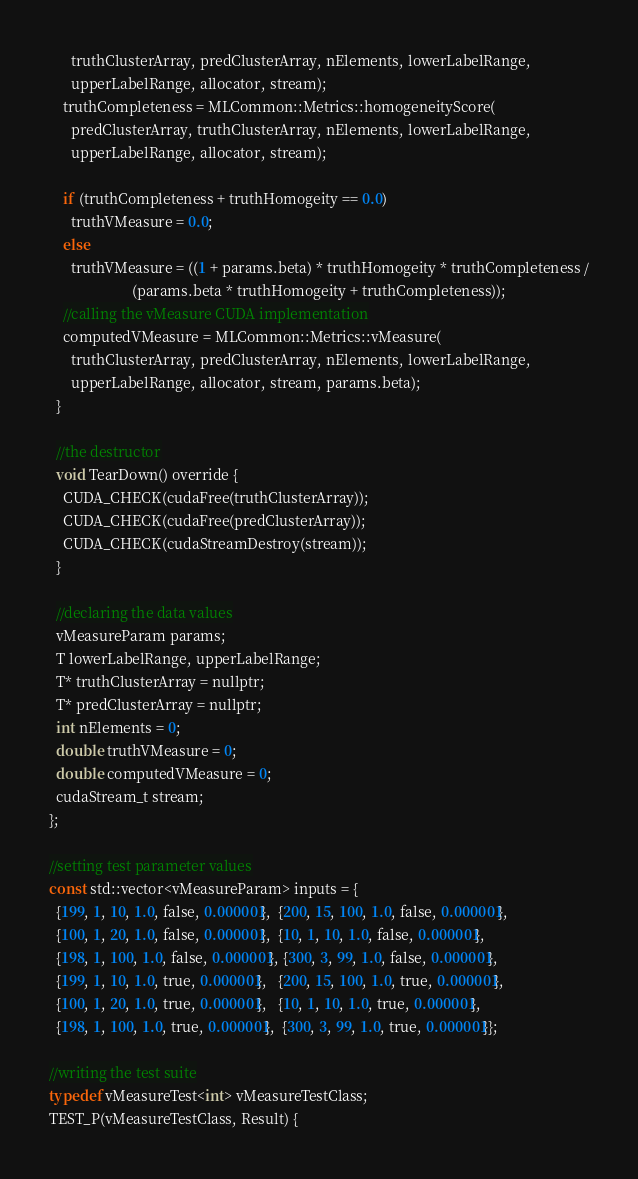<code> <loc_0><loc_0><loc_500><loc_500><_Cuda_>      truthClusterArray, predClusterArray, nElements, lowerLabelRange,
      upperLabelRange, allocator, stream);
    truthCompleteness = MLCommon::Metrics::homogeneityScore(
      predClusterArray, truthClusterArray, nElements, lowerLabelRange,
      upperLabelRange, allocator, stream);

    if (truthCompleteness + truthHomogeity == 0.0)
      truthVMeasure = 0.0;
    else
      truthVMeasure = ((1 + params.beta) * truthHomogeity * truthCompleteness /
                       (params.beta * truthHomogeity + truthCompleteness));
    //calling the vMeasure CUDA implementation
    computedVMeasure = MLCommon::Metrics::vMeasure(
      truthClusterArray, predClusterArray, nElements, lowerLabelRange,
      upperLabelRange, allocator, stream, params.beta);
  }

  //the destructor
  void TearDown() override {
    CUDA_CHECK(cudaFree(truthClusterArray));
    CUDA_CHECK(cudaFree(predClusterArray));
    CUDA_CHECK(cudaStreamDestroy(stream));
  }

  //declaring the data values
  vMeasureParam params;
  T lowerLabelRange, upperLabelRange;
  T* truthClusterArray = nullptr;
  T* predClusterArray = nullptr;
  int nElements = 0;
  double truthVMeasure = 0;
  double computedVMeasure = 0;
  cudaStream_t stream;
};

//setting test parameter values
const std::vector<vMeasureParam> inputs = {
  {199, 1, 10, 1.0, false, 0.000001},  {200, 15, 100, 1.0, false, 0.000001},
  {100, 1, 20, 1.0, false, 0.000001},  {10, 1, 10, 1.0, false, 0.000001},
  {198, 1, 100, 1.0, false, 0.000001}, {300, 3, 99, 1.0, false, 0.000001},
  {199, 1, 10, 1.0, true, 0.000001},   {200, 15, 100, 1.0, true, 0.000001},
  {100, 1, 20, 1.0, true, 0.000001},   {10, 1, 10, 1.0, true, 0.000001},
  {198, 1, 100, 1.0, true, 0.000001},  {300, 3, 99, 1.0, true, 0.000001}};

//writing the test suite
typedef vMeasureTest<int> vMeasureTestClass;
TEST_P(vMeasureTestClass, Result) {</code> 